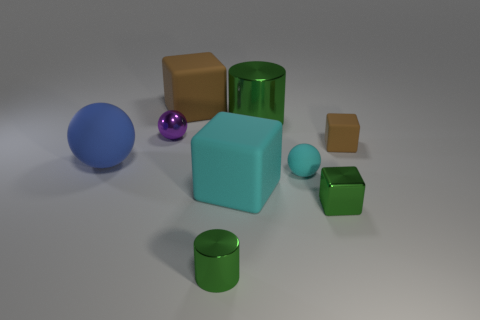Subtract all small green metal cubes. How many cubes are left? 3 Subtract all red spheres. How many brown cubes are left? 2 Subtract all cyan blocks. How many blocks are left? 3 Subtract all cylinders. How many objects are left? 7 Subtract all red spheres. Subtract all blue cubes. How many spheres are left? 3 Subtract all big brown blocks. Subtract all small green metal blocks. How many objects are left? 7 Add 1 big cylinders. How many big cylinders are left? 2 Add 8 large green cylinders. How many large green cylinders exist? 9 Subtract 1 blue balls. How many objects are left? 8 